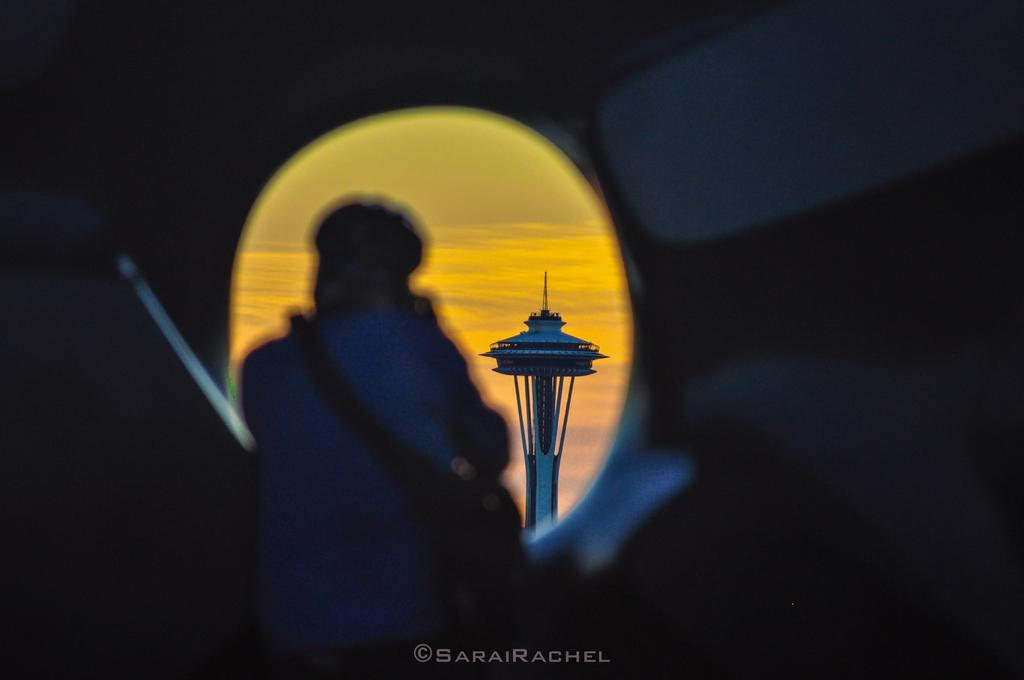What is the main structure in the image? There is a tower in the image. Can you describe any other elements in the image? There is a person in the image. How would you describe the lighting in the image? The image is a little bit dark. Is there any additional information about the image itself? There is a watermark on the bottom side of the image. What is the actor's name in the image? There is no actor present in the image, as it features a tower and a person. What is the person in the image afraid of? There is no indication of fear in the image, as it only shows a person and a tower. 